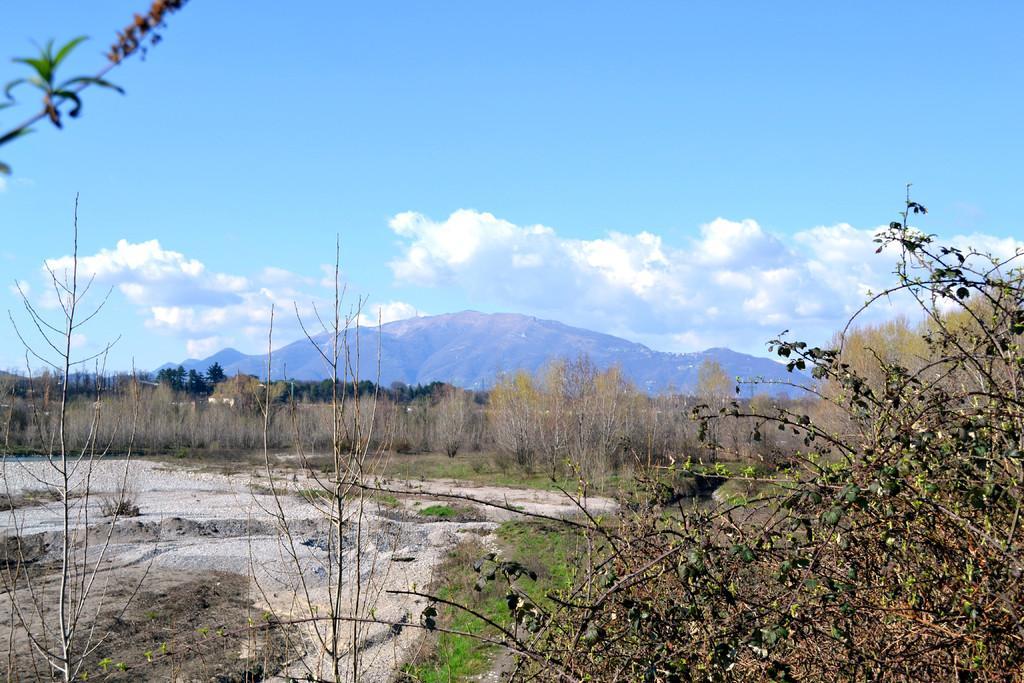In one or two sentences, can you explain what this image depicts? In this image at the bottom, there are plants, and, grass. In the middle there are plants, trees, hills, sky and clouds. 